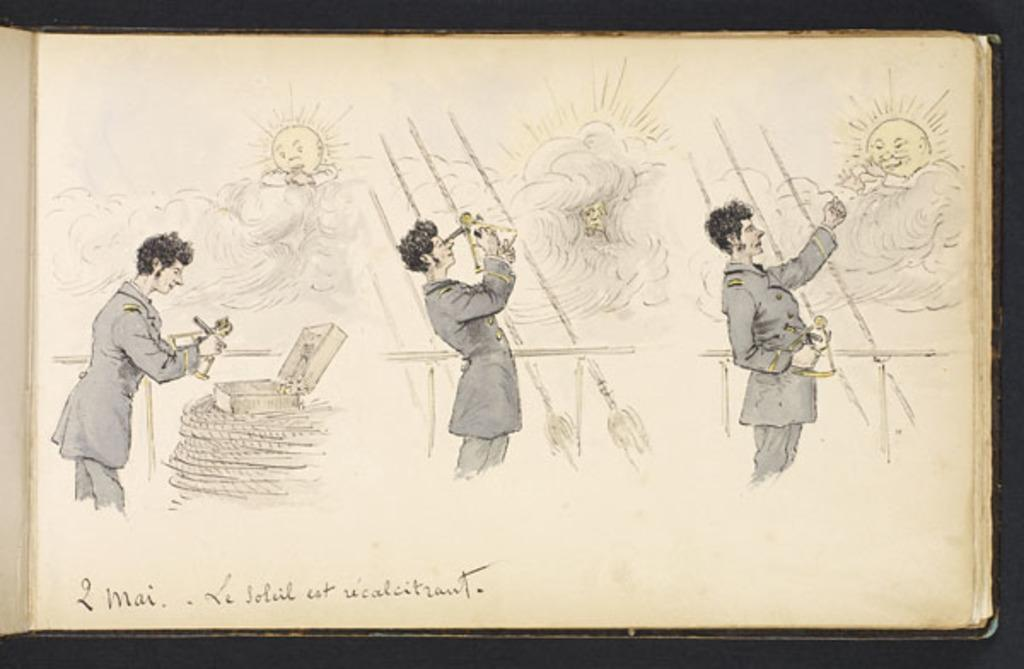What is depicted on the poster in the image? There is a poster of a person in the image. What is the person on the poster doing with their hands? The person on the poster is holding things in their hands. What activity is the person on the poster engaged in? The person on the poster is drawing on a sheet. What type of material can be seen in the image? There are threads visible in the image. What object can be seen in the image? There is a box in the image. What can be seen in the sky in the image? Clouds and the sun are visible in the image. What type of stamp can be seen on the person's forehead in the image? There is no stamp present on the person's forehead in the image. What attempt is the person on the poster making in the image? The image does not depict any attempts or actions related to the person on the poster beyond drawing on a sheet. 